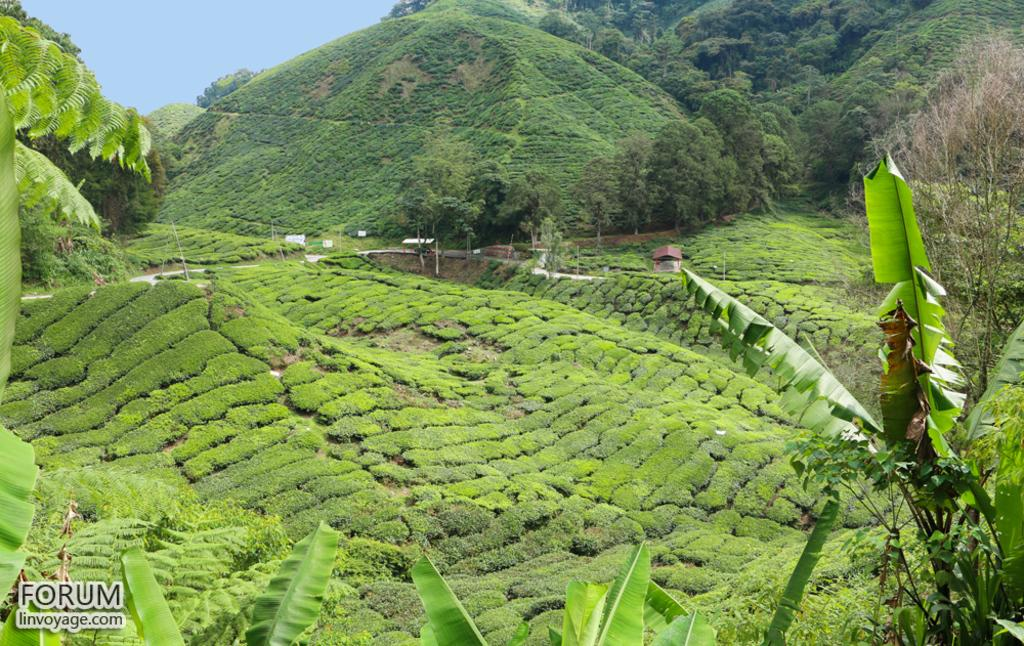What type of landscape is depicted in the image? The image features hills and trees. What can be seen in the background of the image? The sky is visible in the background of the image. Is there any text or marking in the image? Yes, there is a watermark in the bottom left corner of the image. What type of underwear is hanging on the tree in the image? There is no underwear present in the image; it only features hills, trees, and the sky. Can you see any cabbage growing on the hills in the image? There is no cabbage visible in the image; it only features hills, trees, and the sky. 